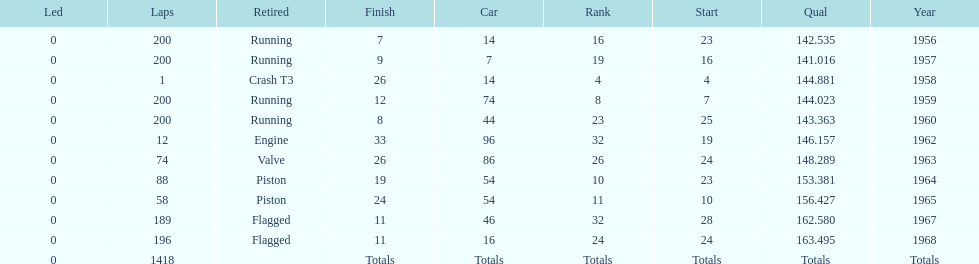What is the larger laps between 1963 or 1968 1968. 